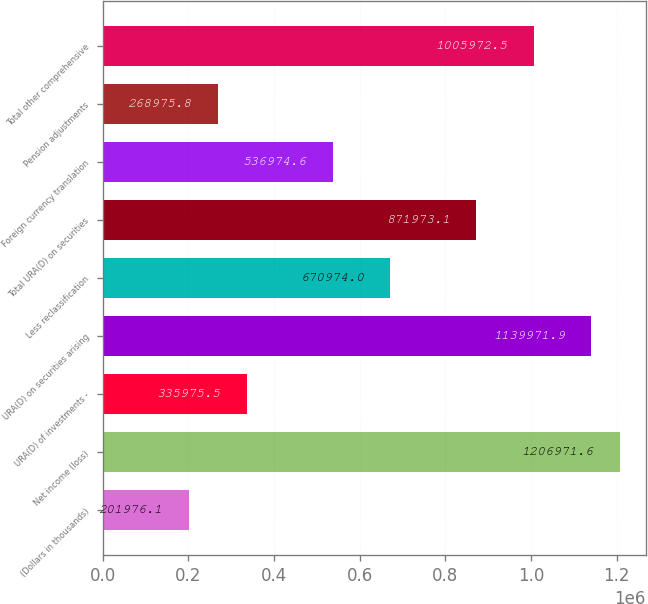Convert chart. <chart><loc_0><loc_0><loc_500><loc_500><bar_chart><fcel>(Dollars in thousands)<fcel>Net income (loss)<fcel>URA(D) of investments -<fcel>URA(D) on securities arising<fcel>Less reclassification<fcel>Total URA(D) on securities<fcel>Foreign currency translation<fcel>Pension adjustments<fcel>Total other comprehensive<nl><fcel>201976<fcel>1.20697e+06<fcel>335976<fcel>1.13997e+06<fcel>670974<fcel>871973<fcel>536975<fcel>268976<fcel>1.00597e+06<nl></chart> 